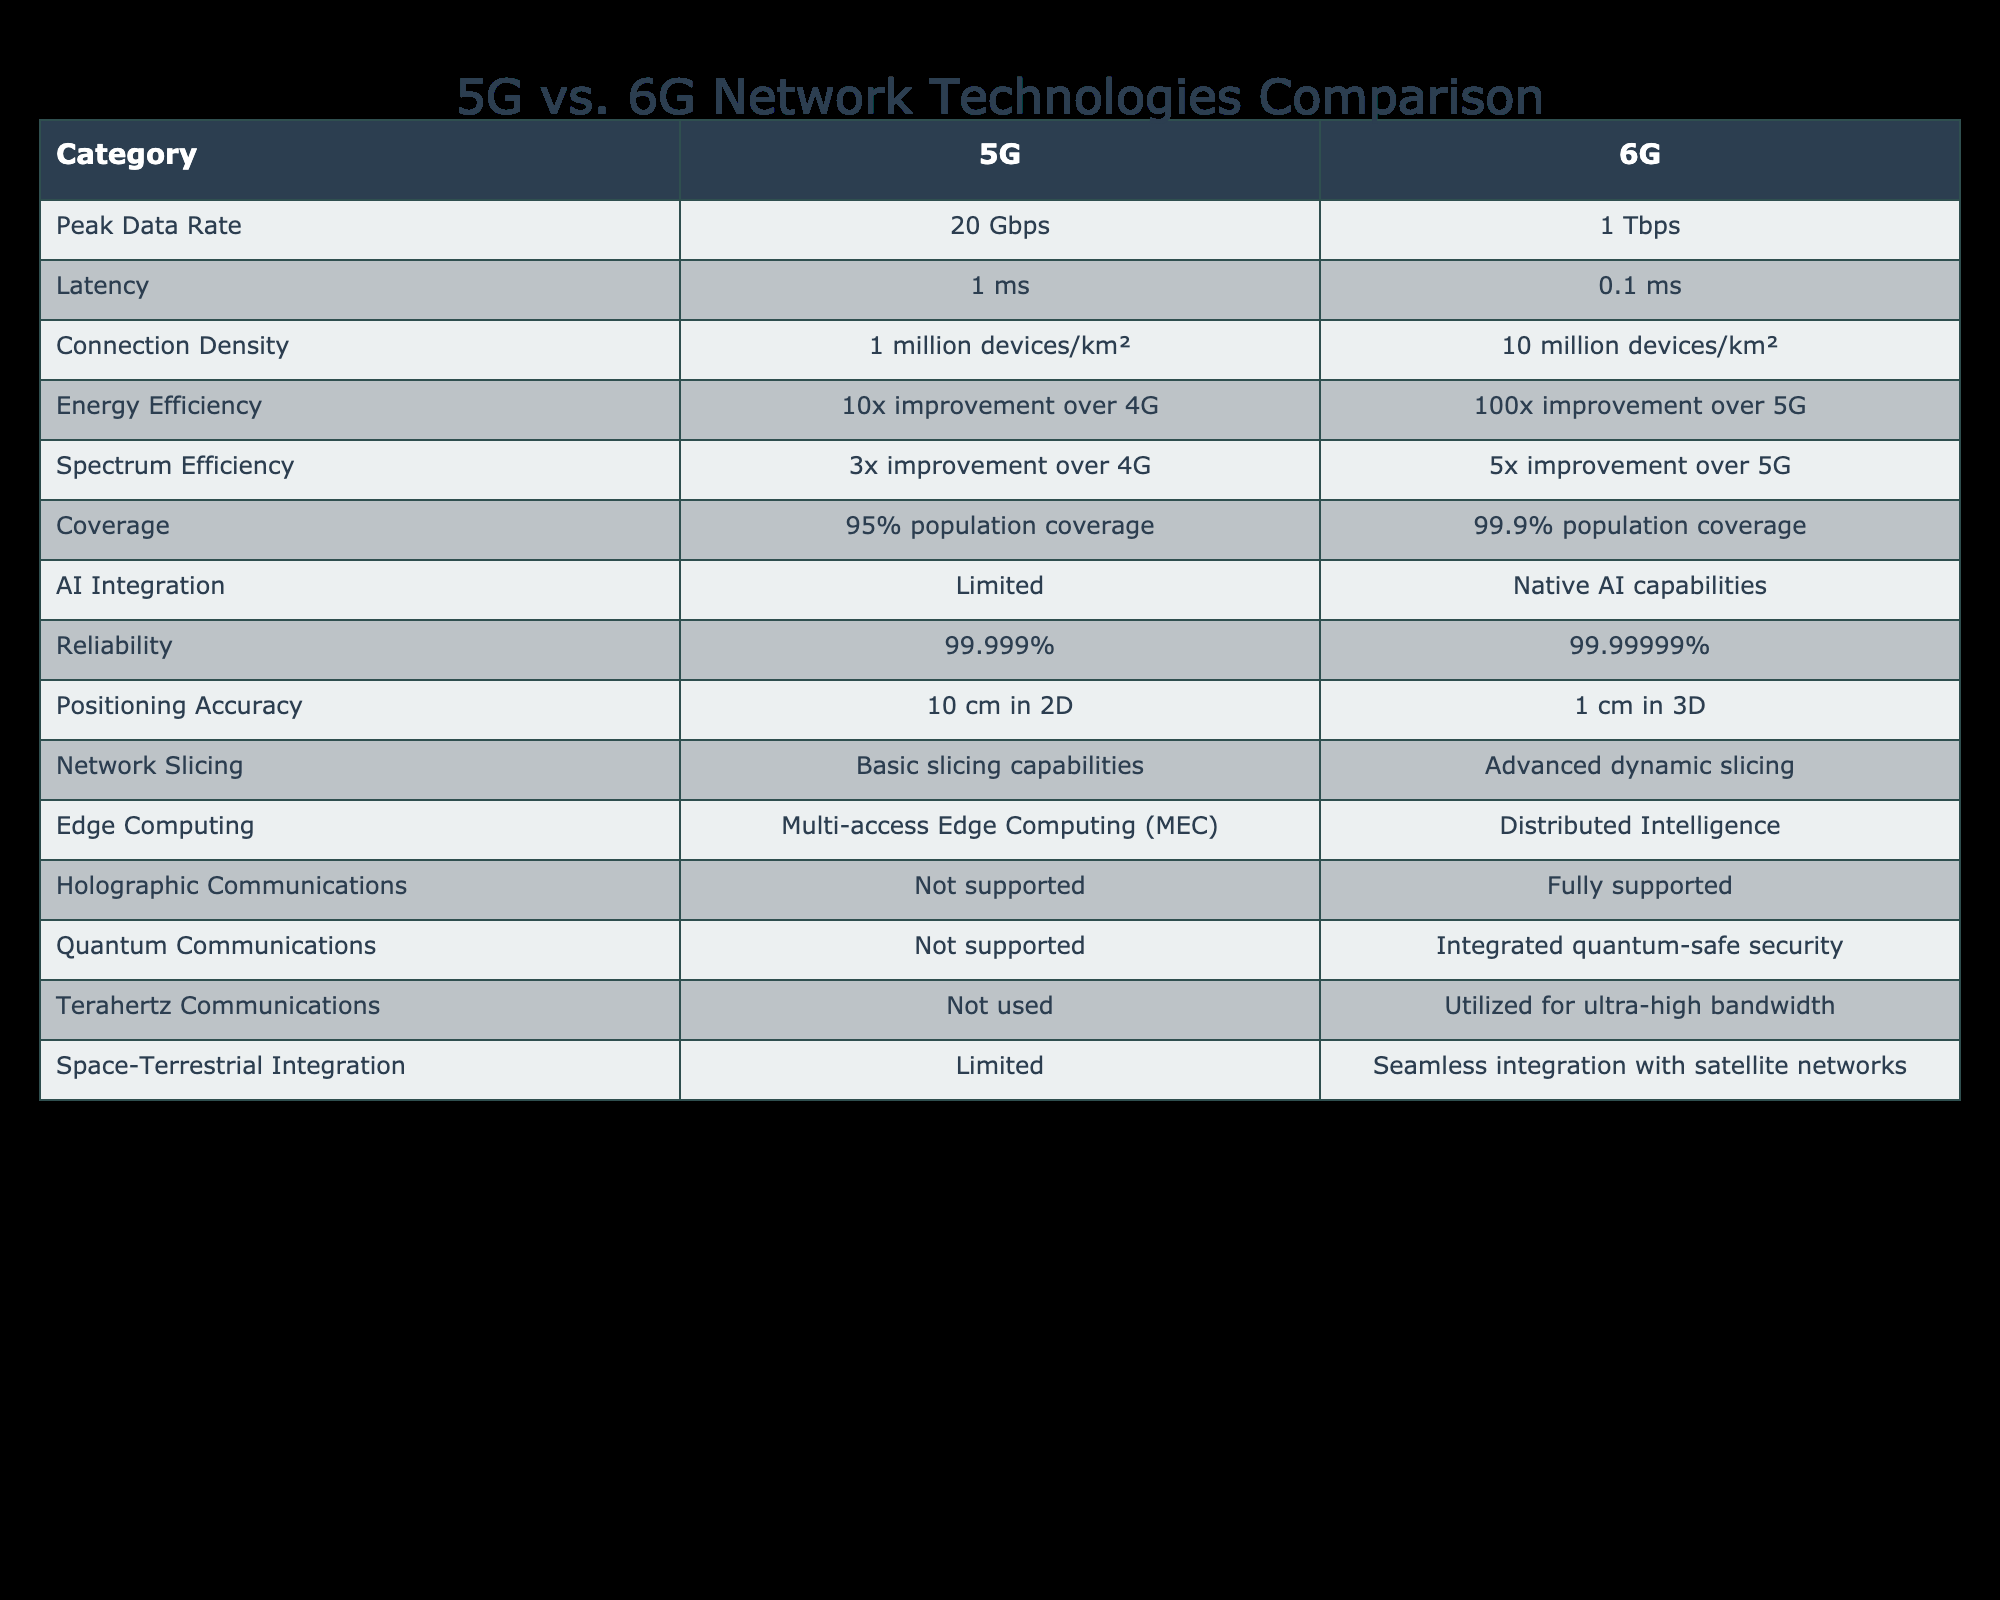What is the expected peak data rate for 6G? The table shows that the peak data rate for 6G is 1 Tbps.
Answer: 1 Tbps How much lower is the latency of 6G compared to 5G? The latency for 5G is 1 ms and for 6G it is 0.1 ms. To find the difference, subtract 0.1 ms from 1 ms, which equals 0.9 ms.
Answer: 0.9 ms Is the energy efficiency improvement of 6G greater than that of 5G? The energy efficiency improvement for 6G is 100x over 5G, while 5G only has a 10x improvement over 4G. Since 100x is greater than 10x, the answer is yes.
Answer: Yes What is the coverage percentage for 5G? Referring to the table, the coverage percentage for 5G is 95%.
Answer: 95% If a city has an area density of 8 million devices, which network can support this density? 5G supports a density of 1 million devices/km² while 6G supports 10 million devices/km². Since 8 million is less than 10 million, only 6G can support this density.
Answer: 6G What is the difference in connection density between 5G and 6G? The connection density for 5G is 1 million devices/km², while for 6G it is 10 million devices/km². The difference is 10 million - 1 million = 9 million devices/km².
Answer: 9 million devices/km² Is holographic communication supported in 5G? The table indicates that 5G does not support holographic communications, while 6G fully supports it. Therefore, the answer is no.
Answer: No Which technology has a better reliability percentage? Checking the reliability percentages, 5G has 99.999% while 6G has 99.99999%. Since 99.99999% is greater, 6G has better reliability.
Answer: 6G How much more energy efficient is 6G compared to 5G? Energy efficiency for 5G is a 10x improvement over 4G, while for 6G it is a 100x improvement over 5G. Therefore, 6G is 10 times more energy efficient than 5G.
Answer: 10 times more 